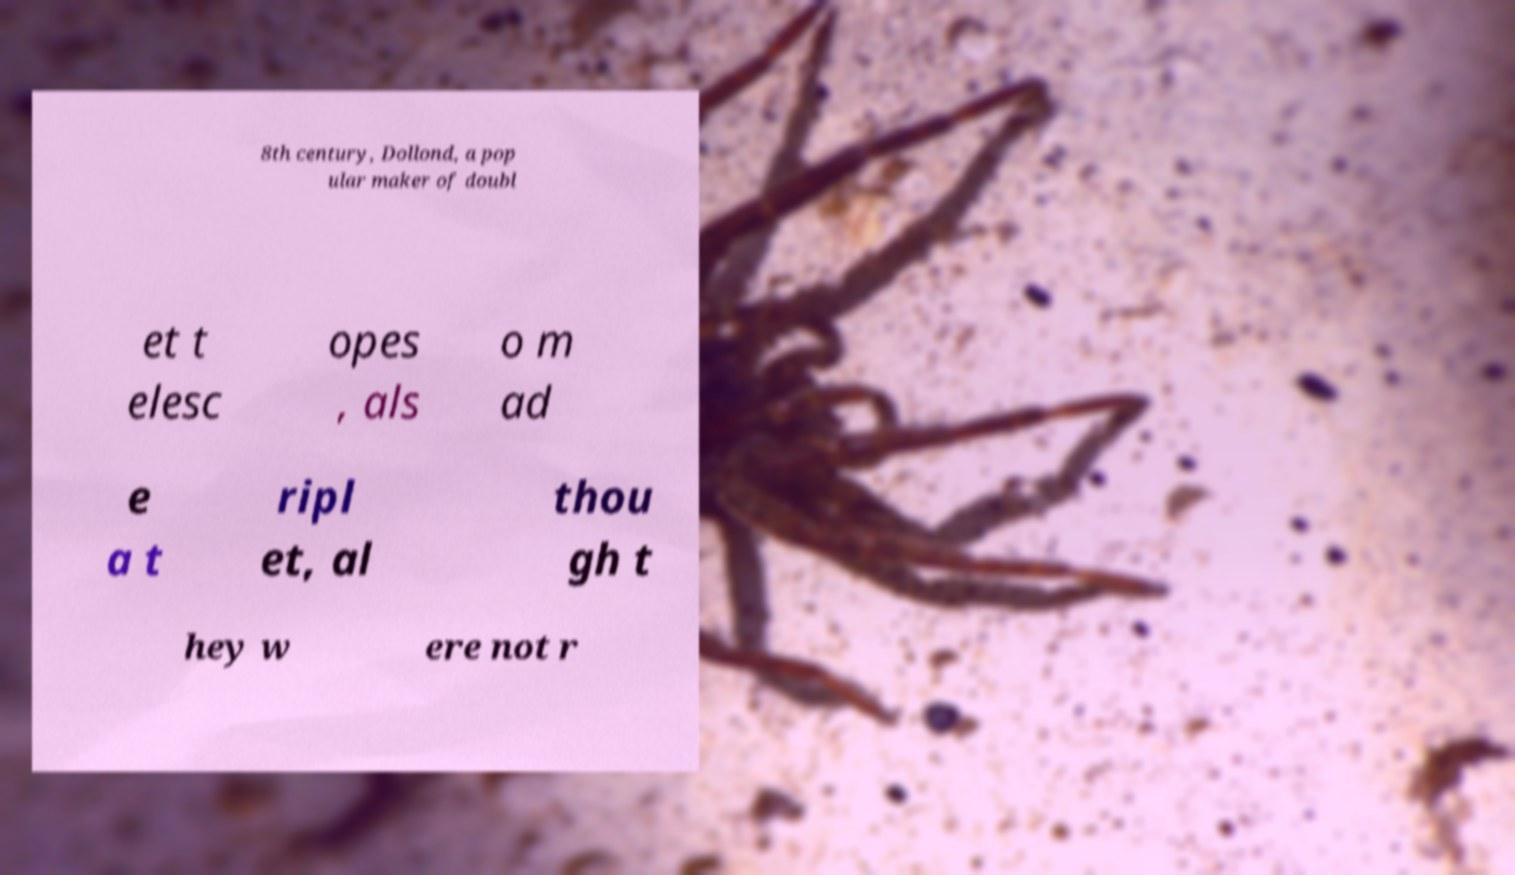There's text embedded in this image that I need extracted. Can you transcribe it verbatim? 8th century, Dollond, a pop ular maker of doubl et t elesc opes , als o m ad e a t ripl et, al thou gh t hey w ere not r 